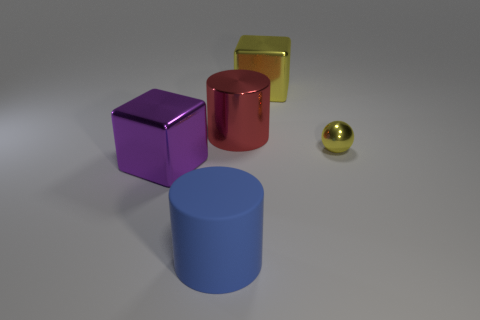What color is the big shiny block that is on the left side of the metal block to the right of the big shiny thing that is left of the big blue cylinder?
Provide a succinct answer. Purple. How many other objects are there of the same shape as the small thing?
Your answer should be very brief. 0. There is a yellow metallic object in front of the big red shiny cylinder; what is its shape?
Keep it short and to the point. Sphere. There is a shiny cube that is in front of the red shiny cylinder; is there a big object on the left side of it?
Your answer should be compact. No. There is a object that is on the right side of the shiny cylinder and behind the yellow shiny ball; what is its color?
Your response must be concise. Yellow. There is a cylinder that is behind the metallic block that is in front of the metallic ball; is there a cylinder on the right side of it?
Offer a terse response. No. What size is the red shiny object that is the same shape as the large blue rubber thing?
Provide a short and direct response. Large. Are there any other things that are made of the same material as the blue object?
Your response must be concise. No. Are there any red shiny things?
Offer a terse response. Yes. Does the ball have the same color as the large cube right of the purple shiny object?
Offer a terse response. Yes. 